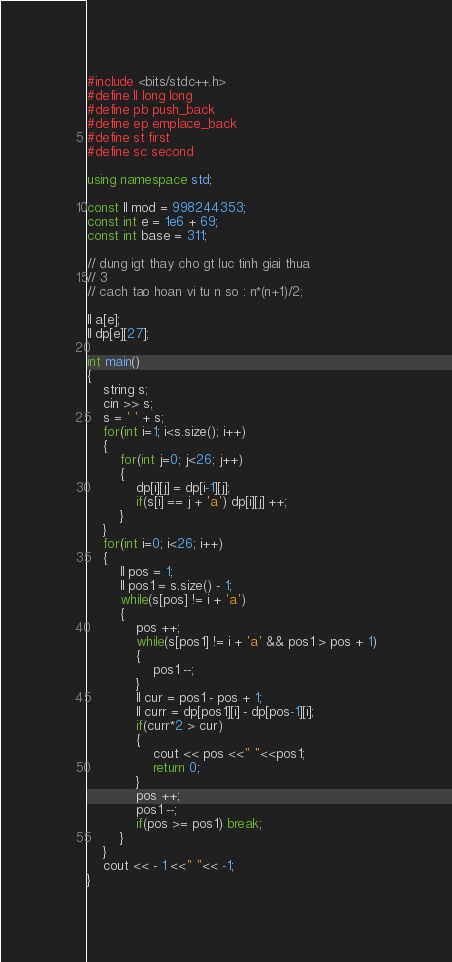<code> <loc_0><loc_0><loc_500><loc_500><_C++_>#include <bits/stdc++.h>
#define ll long long
#define pb push_back
#define ep emplace_back
#define st first
#define sc second

using namespace std;

const ll mod = 998244353;
const int e = 1e6 + 69;
const int base = 311;

// dung igt thay cho gt luc tinh giai thua
// 3
// cach tao hoan vi tu n so : n*(n+1)/2;

ll a[e];
ll dp[e][27];

int main()
{
    string s;
    cin >> s;
    s = ' ' + s;
    for(int i=1; i<s.size(); i++)
    {
        for(int j=0; j<26; j++)
        {
            dp[i][j] = dp[i-1][j];
            if(s[i] == j + 'a') dp[i][j] ++;
        }
    }
    for(int i=0; i<26; i++)
    {
        ll pos = 1;
        ll pos1 = s.size() - 1;
        while(s[pos] != i + 'a')
        {
            pos ++;
            while(s[pos1] != i + 'a' && pos1 > pos + 1)
            {
                pos1 --;
            }
            ll cur = pos1 - pos + 1;
            ll curr = dp[pos1][i] - dp[pos-1][i];
            if(curr*2 > cur)
            {
                cout << pos <<" "<<pos1;
                return 0;
            }
            pos ++;
            pos1 --;
            if(pos >= pos1) break;
        }
    }
    cout << - 1 <<" "<< -1;
}
</code> 